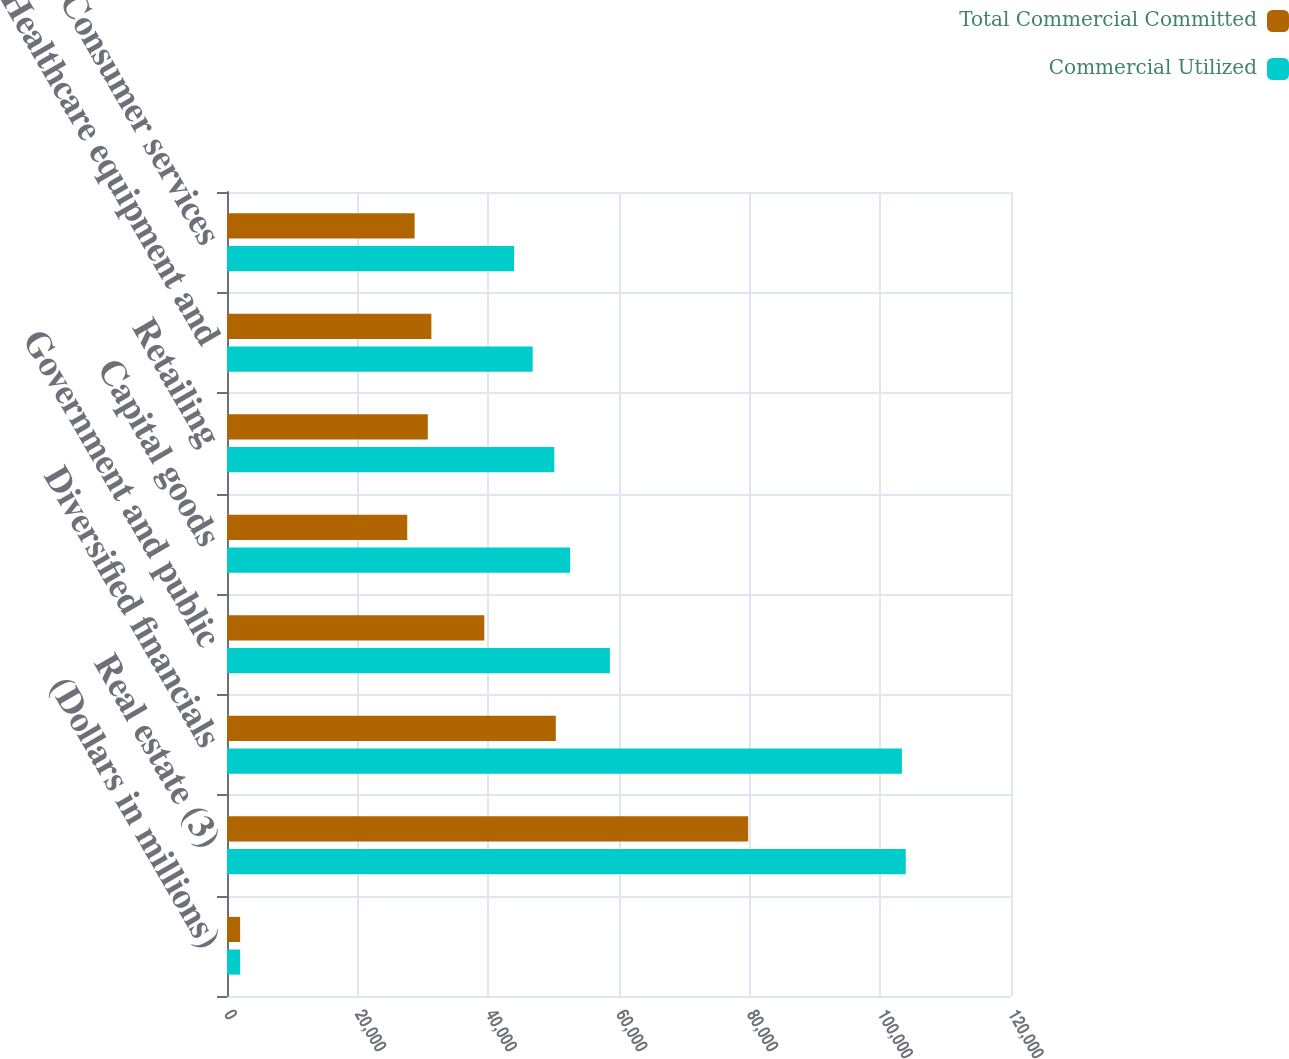Convert chart. <chart><loc_0><loc_0><loc_500><loc_500><stacked_bar_chart><ecel><fcel>(Dollars in millions)<fcel>Real estate (3)<fcel>Diversified financials<fcel>Government and public<fcel>Capital goods<fcel>Retailing<fcel>Healthcare equipment and<fcel>Consumer services<nl><fcel>Total Commercial Committed<fcel>2008<fcel>79766<fcel>50327<fcel>39386<fcel>27588<fcel>30736<fcel>31280<fcel>28715<nl><fcel>Commercial Utilized<fcel>2008<fcel>103889<fcel>103306<fcel>58608<fcel>52522<fcel>50102<fcel>46785<fcel>43948<nl></chart> 